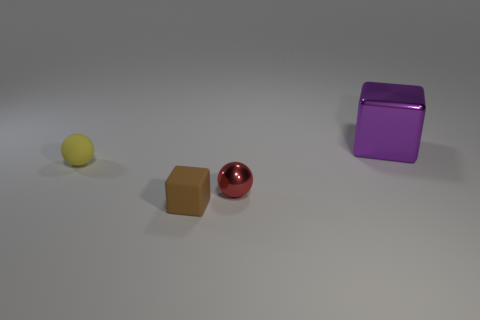Are there any other things that are the same size as the purple shiny thing?
Offer a terse response. No. How many red things are either tiny objects or tiny metallic spheres?
Make the answer very short. 1. Do the tiny red sphere and the tiny yellow sphere have the same material?
Make the answer very short. No. How many tiny brown matte objects are left of the small ball that is right of the tiny brown object?
Provide a succinct answer. 1. Do the metal ball and the brown matte object have the same size?
Make the answer very short. Yes. What number of tiny yellow spheres have the same material as the purple cube?
Offer a terse response. 0. What is the size of the rubber object that is the same shape as the small red shiny object?
Offer a very short reply. Small. Does the tiny rubber thing that is to the right of the tiny yellow rubber ball have the same shape as the big purple object?
Offer a terse response. Yes. There is a metallic object that is in front of the tiny matte thing that is to the left of the rubber block; what shape is it?
Offer a terse response. Sphere. Is there anything else that has the same shape as the tiny yellow object?
Offer a terse response. Yes. 